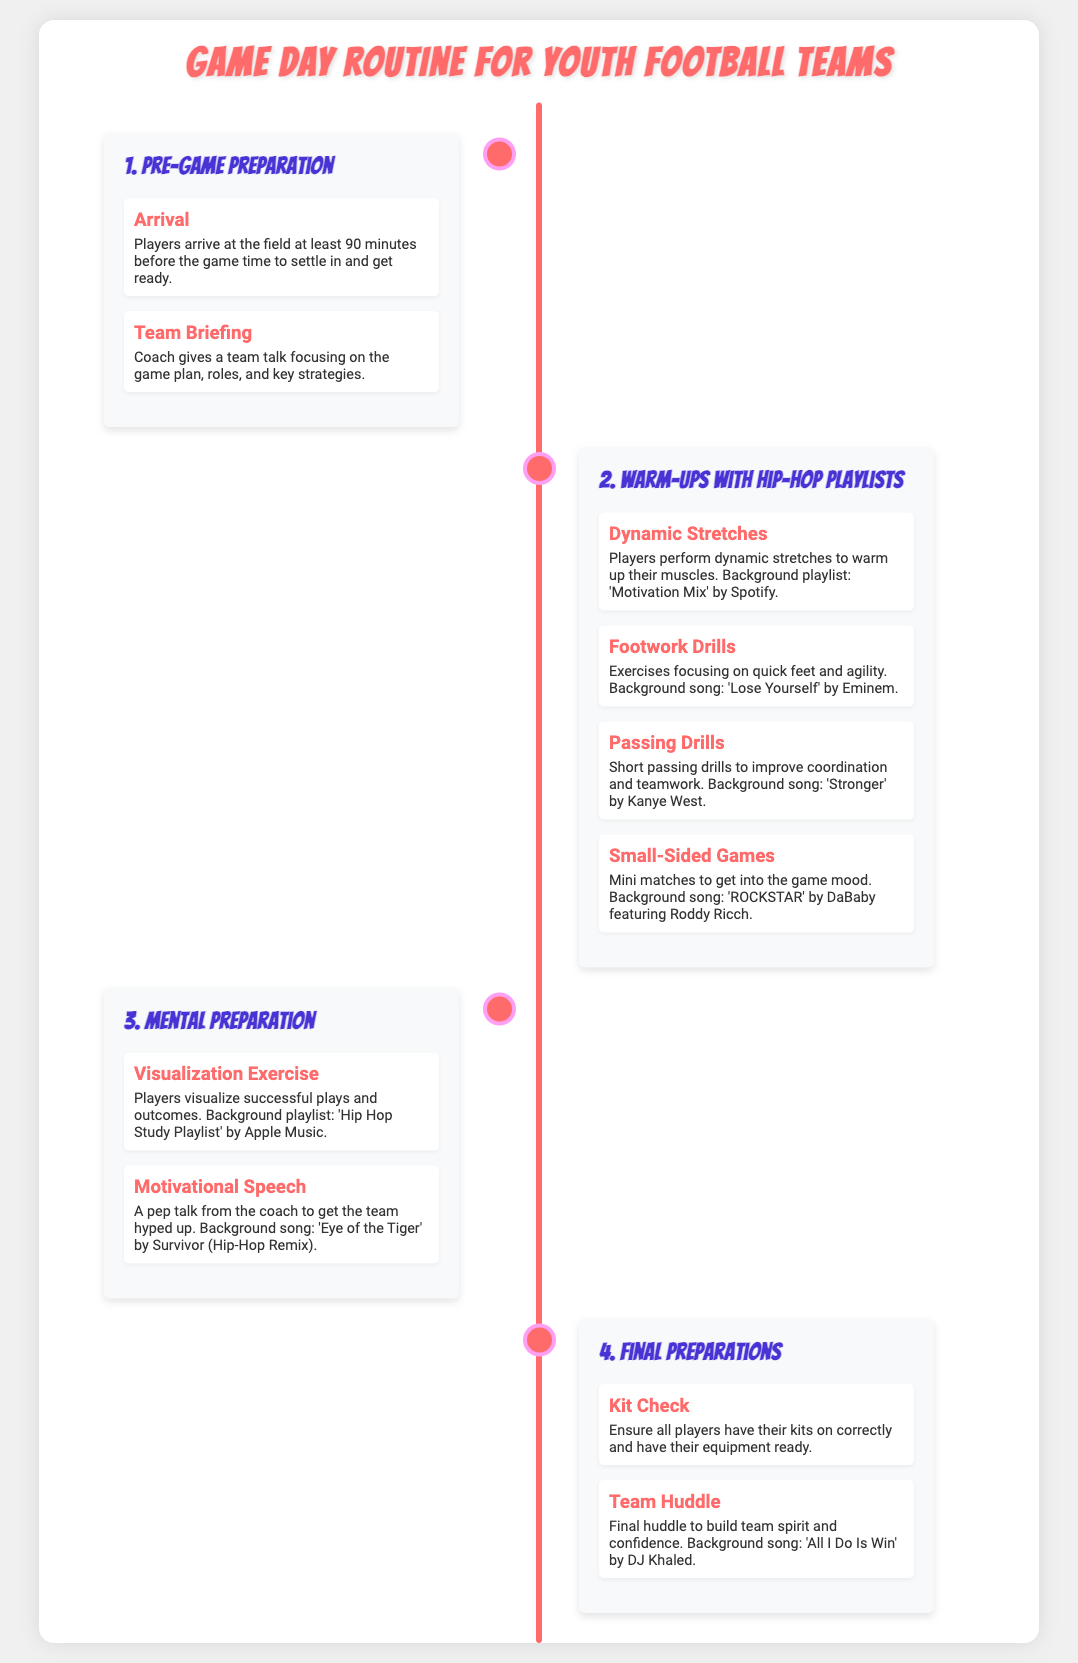What time should players arrive at the field? Players are advised to arrive at least 90 minutes before the game time, allowing time to settle in.
Answer: 90 minutes What is the background playlist during dynamic stretches? The background playlist for dynamic stretches is 'Motivation Mix' by Spotify, which helps set a positive tone.
Answer: Motivation Mix Which song plays during the footwork drills? The song playing during footwork drills is 'Lose Yourself' by Eminem, providing an energizing atmosphere.
Answer: Lose Yourself What is the focus of the team briefing? The team briefing focuses on the game plan, roles, and key strategies to prepare the team.
Answer: Game plan What exercise helps players visualize successful plays? Players engage in a visualization exercise to envision successful plays and outcomes as part of their mental prep.
Answer: Visualization exercise What song provides a pep talk atmosphere? The motivational speech is accompanied by 'Eye of the Tiger' by Survivor (Hip-Hop Remix) to hype up the team.
Answer: Eye of the Tiger What is checked during the kit check? During the kit check, all players ensure that their kits are worn correctly and have their equipment ready for the game.
Answer: Kits What activity fosters team spirit before the game? The final huddle is the activity that builds team spirit and confidence before the game.
Answer: Team Huddle What type of drills are performed before the game? Various warm-up drills are performed, including footwork drills, to enhance players' readiness.
Answer: Warm-up drills 